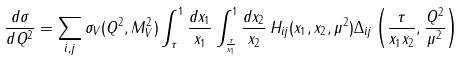Convert formula to latex. <formula><loc_0><loc_0><loc_500><loc_500>\frac { d \sigma } { d Q ^ { 2 } } = \sum _ { i , j } \sigma _ { V } ( Q ^ { 2 } , M _ { V } ^ { 2 } ) \int _ { \tau } ^ { 1 } \frac { d x _ { 1 } } { x _ { 1 } } \int _ { \frac { \tau } { x _ { 1 } } } ^ { 1 } \frac { d x _ { 2 } } { x _ { 2 } } \, H _ { i j } ( x _ { 1 } , x _ { 2 } , \mu ^ { 2 } ) \Delta _ { i j } \left ( \frac { \tau } { x _ { 1 } x _ { 2 } } , \frac { Q ^ { 2 } } { \mu ^ { 2 } } \right )</formula> 